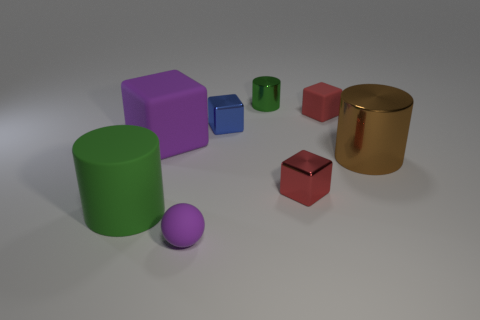Do the tiny sphere and the big rubber thing behind the big shiny object have the same color?
Offer a terse response. Yes. What number of cylinders are either tiny red things or tiny green objects?
Keep it short and to the point. 1. The tiny object that is to the left of the blue object is what color?
Offer a very short reply. Purple. There is a thing that is the same color as the small matte ball; what is its shape?
Your response must be concise. Cube. How many red shiny cubes are the same size as the blue shiny cube?
Give a very brief answer. 1. There is a rubber thing right of the purple matte ball; is its shape the same as the green object in front of the tiny red metallic thing?
Provide a short and direct response. No. What material is the big brown cylinder to the right of the metallic cylinder that is on the left side of the tiny rubber object that is behind the large brown metallic cylinder made of?
Your response must be concise. Metal. There is a blue object that is the same size as the red matte block; what is its shape?
Make the answer very short. Cube. Is there a thing that has the same color as the sphere?
Ensure brevity in your answer.  Yes. What is the size of the blue thing?
Ensure brevity in your answer.  Small. 